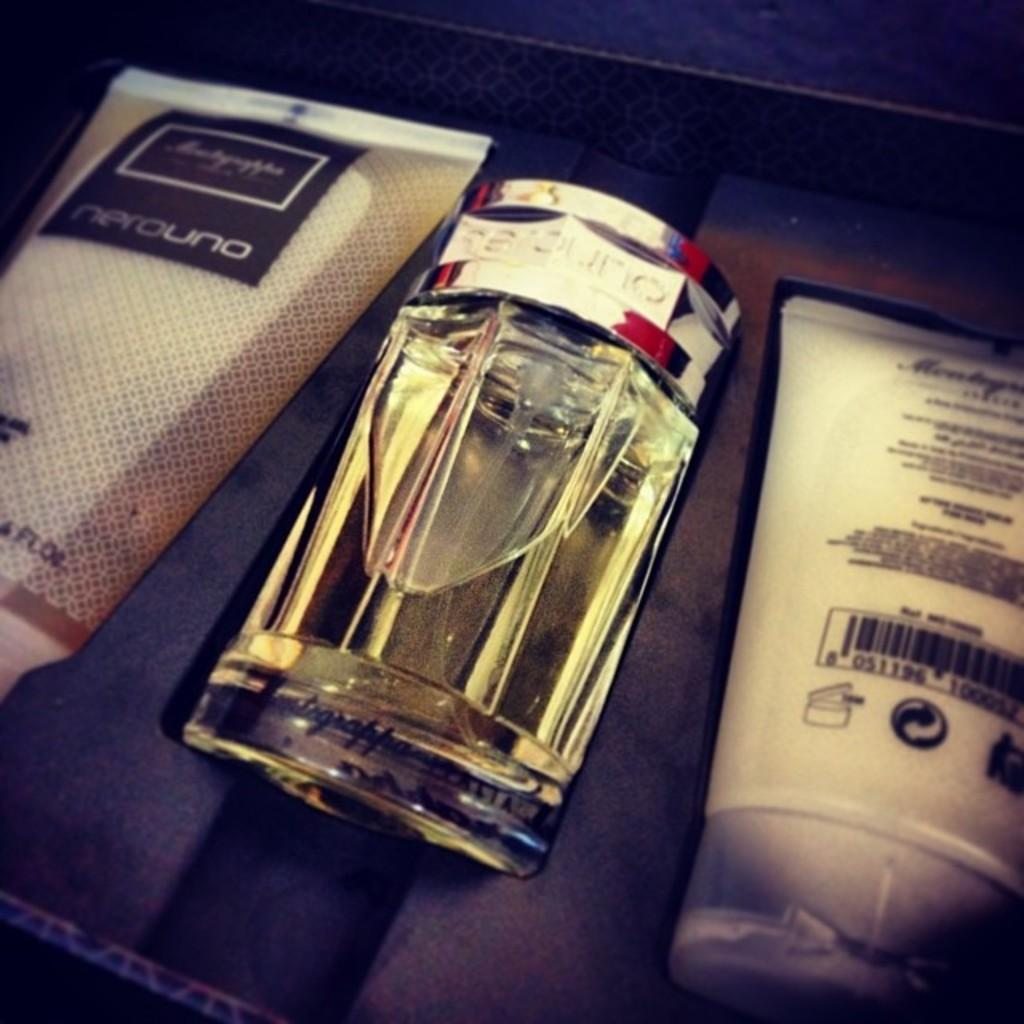Provide a one-sentence caption for the provided image. The cologne and lotion gift set is NeroUno brand. 